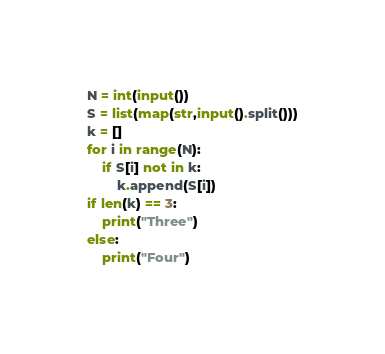Convert code to text. <code><loc_0><loc_0><loc_500><loc_500><_Python_>N = int(input())
S = list(map(str,input().split()))
k = []
for i in range(N):
    if S[i] not in k:
        k.append(S[i])
if len(k) == 3:
    print("Three")
else:
    print("Four")</code> 